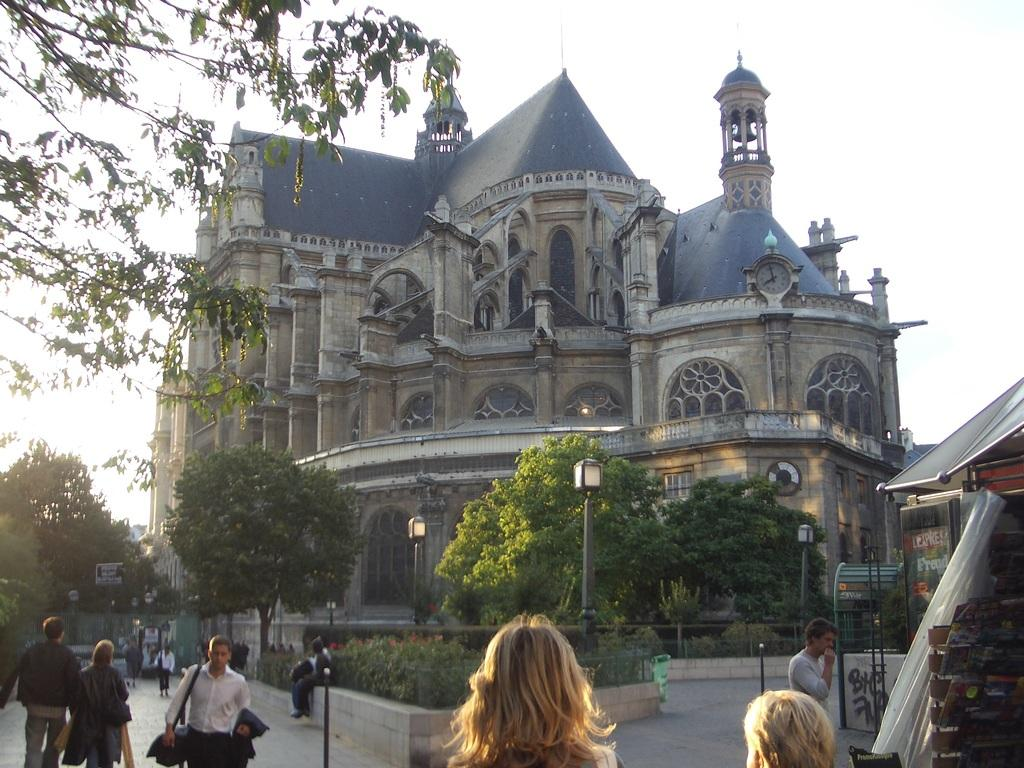What type of structure is visible in the image? There is a building in the image. What natural elements can be seen in the image? There are trees in the image. Where are the people located in the image? The people are standing on the road outside the building. What is the price of the whistle in the image? There is no whistle present in the image, so it is not possible to determine its price. 